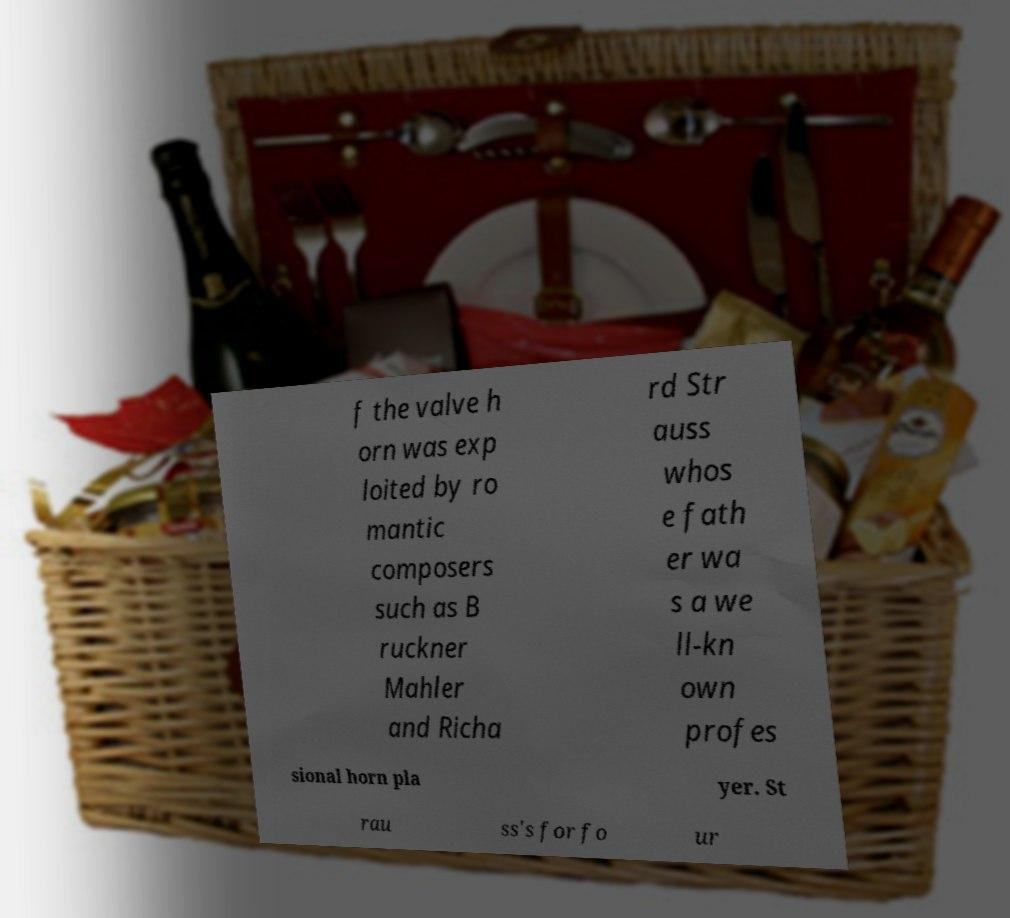Can you accurately transcribe the text from the provided image for me? f the valve h orn was exp loited by ro mantic composers such as B ruckner Mahler and Richa rd Str auss whos e fath er wa s a we ll-kn own profes sional horn pla yer. St rau ss's for fo ur 